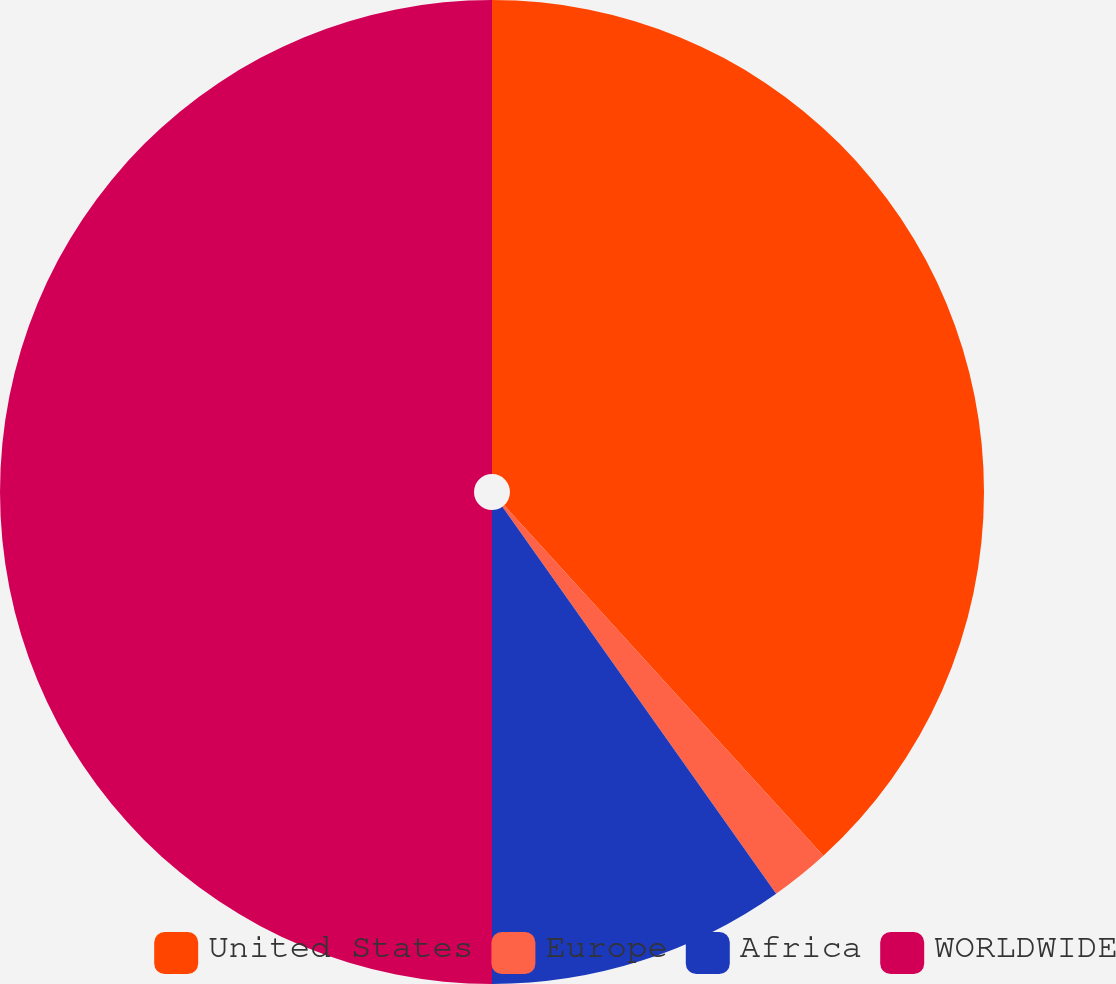<chart> <loc_0><loc_0><loc_500><loc_500><pie_chart><fcel>United States<fcel>Europe<fcel>Africa<fcel>WORLDWIDE<nl><fcel>38.24%<fcel>1.96%<fcel>9.8%<fcel>50.0%<nl></chart> 